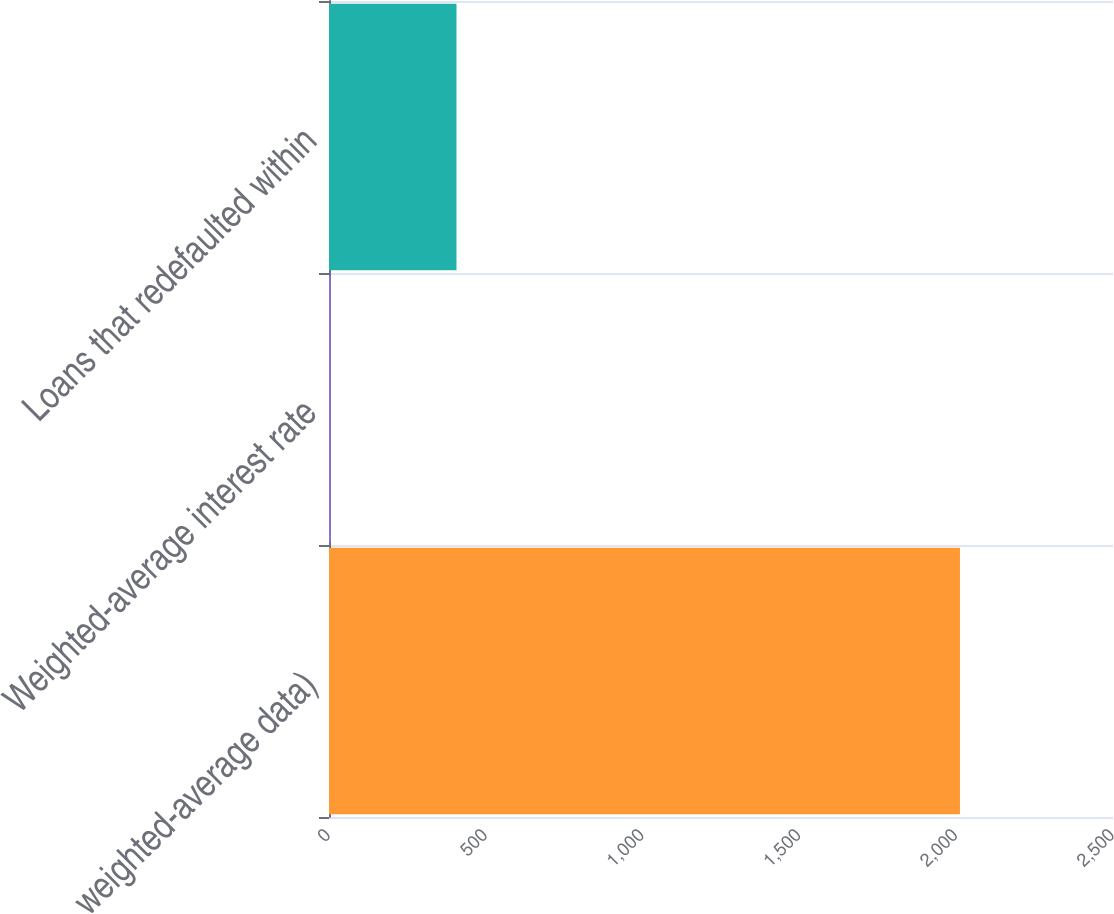Convert chart. <chart><loc_0><loc_0><loc_500><loc_500><bar_chart><fcel>weighted-average data)<fcel>Weighted-average interest rate<fcel>Loans that redefaulted within<nl><fcel>2012<fcel>5.19<fcel>406.55<nl></chart> 